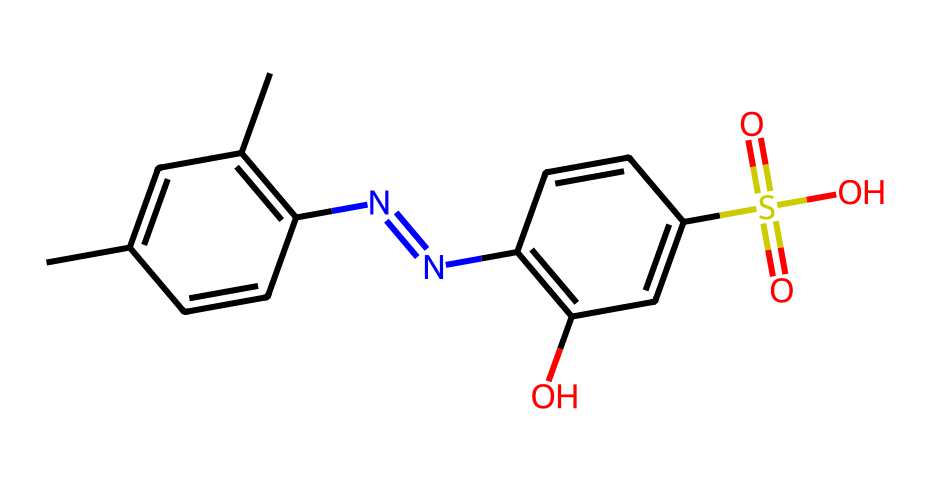What is the primary functional group present in this structure? The structure contains a sulfonic acid group (-SO3H), which is identifiable by the sulfur atom bonded to three oxygen atoms, one of which has a hydrogen attached.
Answer: sulfonic acid How many nitrogen atoms are present in this molecule? Upon inspecting the SMILES representation, we can identify two nitrogen atoms, which are indicated by the 'N' symbols in the structure.
Answer: two What is the total number of carbon atoms in this structure? By counting the carbon atoms represented by 'C' in the SMILES string, we find there are twelve carbon atoms throughout the entire structure.
Answer: twelve Does this chemical structure include any aromatic rings? The presence of alternating double bonds in the core structure indicates the presence of aromaticity, confirming the existence of aromatic rings within the compound.
Answer: yes What property makes DNQ-based photoresists suitable for genetic sequencing chips? The presence of the DNQ (diazoketone) moiety contributes to the chemical's sensitivity to UV light, which is crucial for the precise patterning needed in genetic sequencing applications.
Answer: UV sensitivity 